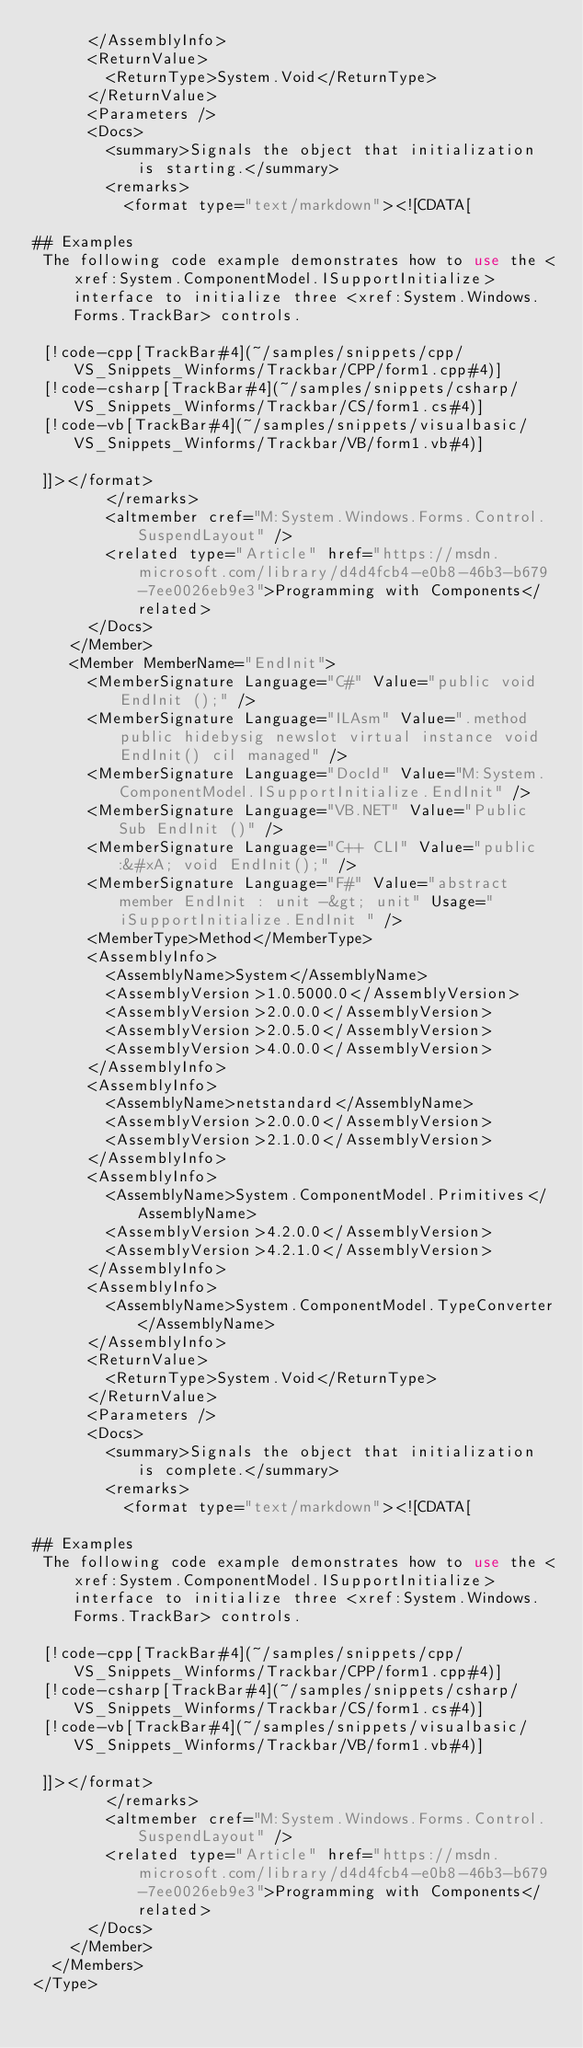<code> <loc_0><loc_0><loc_500><loc_500><_XML_>      </AssemblyInfo>
      <ReturnValue>
        <ReturnType>System.Void</ReturnType>
      </ReturnValue>
      <Parameters />
      <Docs>
        <summary>Signals the object that initialization is starting.</summary>
        <remarks>
          <format type="text/markdown"><![CDATA[  
  
## Examples  
 The following code example demonstrates how to use the <xref:System.ComponentModel.ISupportInitialize> interface to initialize three <xref:System.Windows.Forms.TrackBar> controls.  
  
 [!code-cpp[TrackBar#4](~/samples/snippets/cpp/VS_Snippets_Winforms/Trackbar/CPP/form1.cpp#4)]
 [!code-csharp[TrackBar#4](~/samples/snippets/csharp/VS_Snippets_Winforms/Trackbar/CS/form1.cs#4)]
 [!code-vb[TrackBar#4](~/samples/snippets/visualbasic/VS_Snippets_Winforms/Trackbar/VB/form1.vb#4)]  
  
 ]]></format>
        </remarks>
        <altmember cref="M:System.Windows.Forms.Control.SuspendLayout" />
        <related type="Article" href="https://msdn.microsoft.com/library/d4d4fcb4-e0b8-46b3-b679-7ee0026eb9e3">Programming with Components</related>
      </Docs>
    </Member>
    <Member MemberName="EndInit">
      <MemberSignature Language="C#" Value="public void EndInit ();" />
      <MemberSignature Language="ILAsm" Value=".method public hidebysig newslot virtual instance void EndInit() cil managed" />
      <MemberSignature Language="DocId" Value="M:System.ComponentModel.ISupportInitialize.EndInit" />
      <MemberSignature Language="VB.NET" Value="Public Sub EndInit ()" />
      <MemberSignature Language="C++ CLI" Value="public:&#xA; void EndInit();" />
      <MemberSignature Language="F#" Value="abstract member EndInit : unit -&gt; unit" Usage="iSupportInitialize.EndInit " />
      <MemberType>Method</MemberType>
      <AssemblyInfo>
        <AssemblyName>System</AssemblyName>
        <AssemblyVersion>1.0.5000.0</AssemblyVersion>
        <AssemblyVersion>2.0.0.0</AssemblyVersion>
        <AssemblyVersion>2.0.5.0</AssemblyVersion>
        <AssemblyVersion>4.0.0.0</AssemblyVersion>
      </AssemblyInfo>
      <AssemblyInfo>
        <AssemblyName>netstandard</AssemblyName>
        <AssemblyVersion>2.0.0.0</AssemblyVersion>
        <AssemblyVersion>2.1.0.0</AssemblyVersion>
      </AssemblyInfo>
      <AssemblyInfo>
        <AssemblyName>System.ComponentModel.Primitives</AssemblyName>
        <AssemblyVersion>4.2.0.0</AssemblyVersion>
        <AssemblyVersion>4.2.1.0</AssemblyVersion>
      </AssemblyInfo>
      <AssemblyInfo>
        <AssemblyName>System.ComponentModel.TypeConverter</AssemblyName>
      </AssemblyInfo>
      <ReturnValue>
        <ReturnType>System.Void</ReturnType>
      </ReturnValue>
      <Parameters />
      <Docs>
        <summary>Signals the object that initialization is complete.</summary>
        <remarks>
          <format type="text/markdown"><![CDATA[  
  
## Examples  
 The following code example demonstrates how to use the <xref:System.ComponentModel.ISupportInitialize> interface to initialize three <xref:System.Windows.Forms.TrackBar> controls.  
  
 [!code-cpp[TrackBar#4](~/samples/snippets/cpp/VS_Snippets_Winforms/Trackbar/CPP/form1.cpp#4)]
 [!code-csharp[TrackBar#4](~/samples/snippets/csharp/VS_Snippets_Winforms/Trackbar/CS/form1.cs#4)]
 [!code-vb[TrackBar#4](~/samples/snippets/visualbasic/VS_Snippets_Winforms/Trackbar/VB/form1.vb#4)]  
  
 ]]></format>
        </remarks>
        <altmember cref="M:System.Windows.Forms.Control.SuspendLayout" />
        <related type="Article" href="https://msdn.microsoft.com/library/d4d4fcb4-e0b8-46b3-b679-7ee0026eb9e3">Programming with Components</related>
      </Docs>
    </Member>
  </Members>
</Type>
</code> 